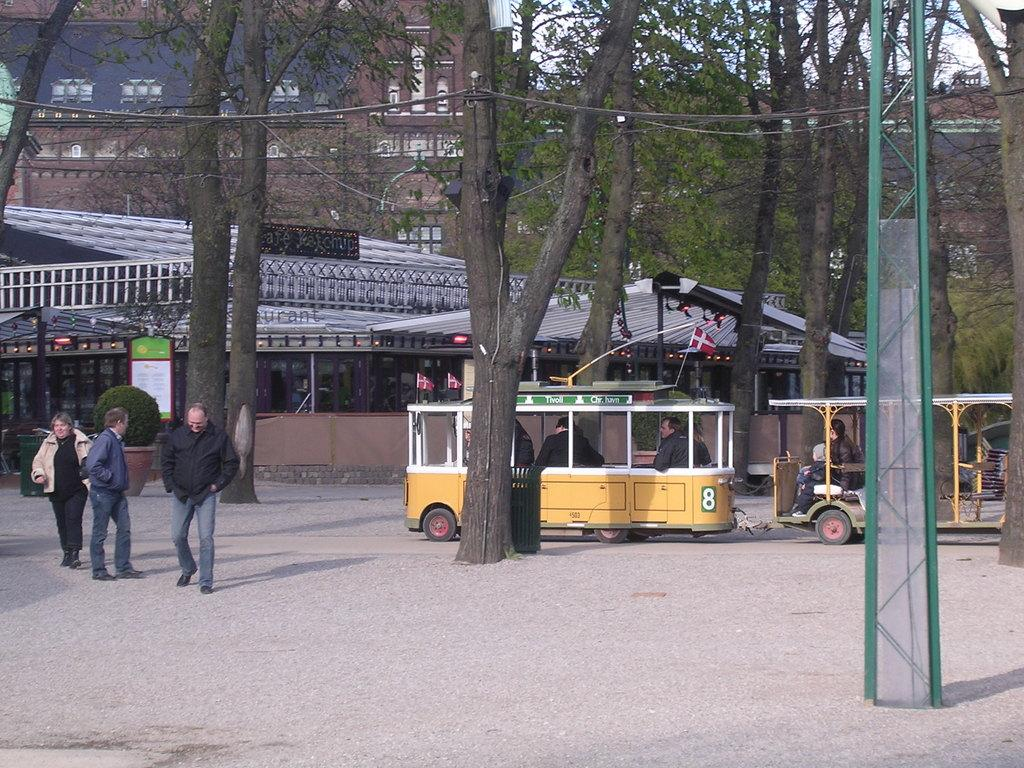<image>
Render a clear and concise summary of the photo. A yellow trolley that has the number 8 on it takes people though a park. 